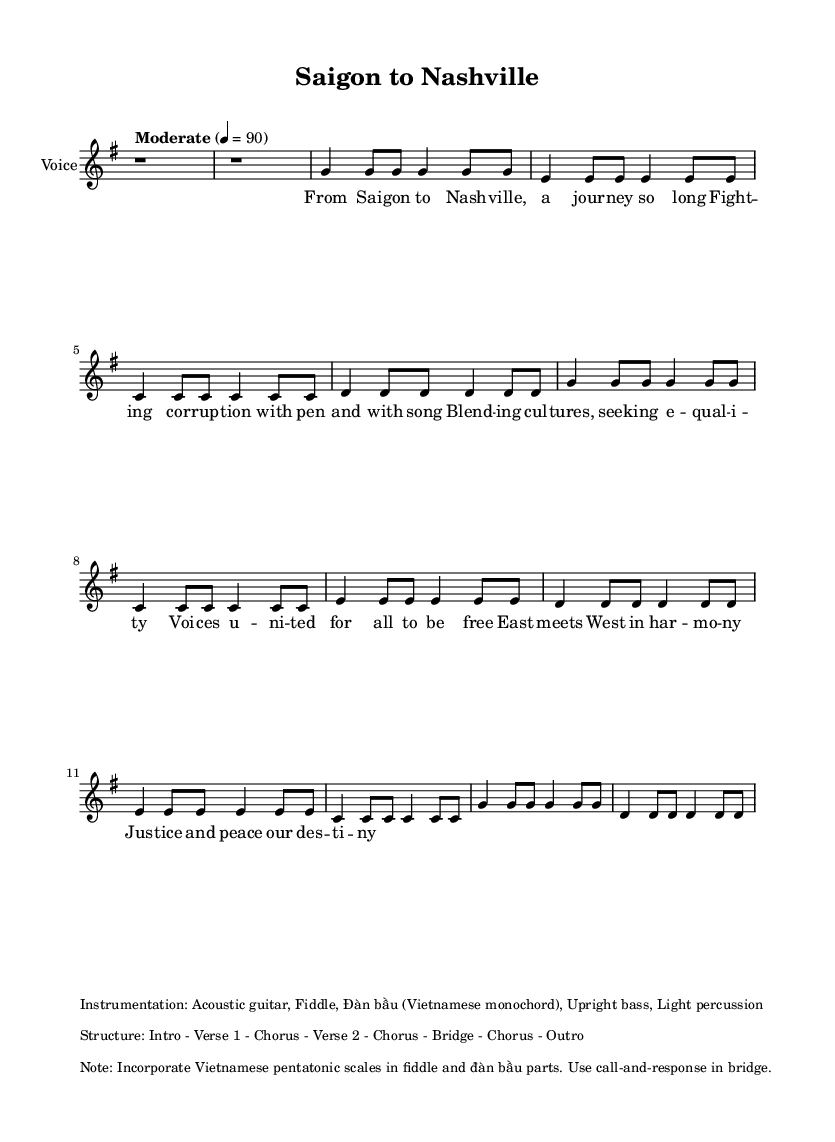What is the key signature of this music? The key signature is G major, which has one sharp (F#) indicated at the beginning of the staff.
Answer: G major What is the time signature of this piece? The time signature shown at the beginning is 4/4, which means there are four beats in each measure, and each quarter note receives one beat.
Answer: 4/4 What is the tempo marking for this piece? The tempo is marked as "Moderate" with a metronome marking of 90 beats per minute, indicating a moderate pace for the performance.
Answer: Moderate, 90 How many verses are in the structure of the song? The structure of the song includes two verses, as it explicitly mentions "Verse 1" and "Verse 2" in the layout details.
Answer: 2 What instrument is primarily used in the melody? The melody is written for "Voice", which indicates that the primary instrument for this piece is the human voice.
Answer: Voice What musical element is used in the bridge section? The bridge section incorporates a call-and-response format, which is a traditional technique often used in folk music to engage the audience and add depth to the performance.
Answer: Call-and-response What cultural influences are blended in this piece? The lyrics and instrumentation reflect a blend of Vietnamese and American cultures, as indicated by the merging of contemporary country-folk with Vietnamese musical elements.
Answer: Vietnamese and American cultures 